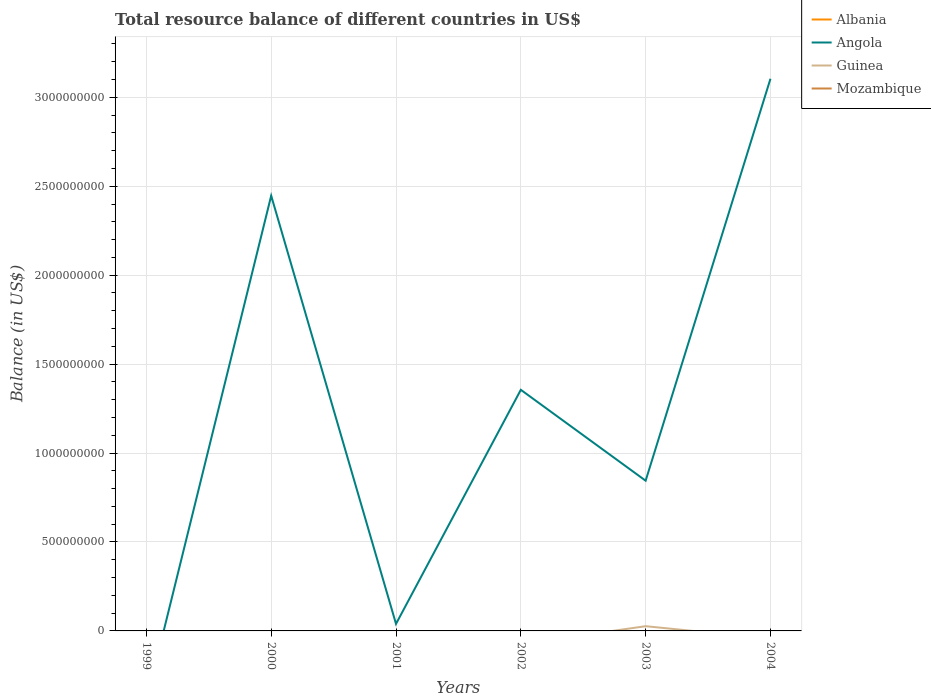How many different coloured lines are there?
Offer a very short reply. 2. Does the line corresponding to Angola intersect with the line corresponding to Mozambique?
Your answer should be very brief. No. Is the number of lines equal to the number of legend labels?
Offer a very short reply. No. What is the total total resource balance in Angola in the graph?
Your answer should be compact. -3.06e+09. What is the difference between the highest and the second highest total resource balance in Angola?
Give a very brief answer. 3.10e+09. How many lines are there?
Make the answer very short. 2. How many years are there in the graph?
Keep it short and to the point. 6. Are the values on the major ticks of Y-axis written in scientific E-notation?
Provide a short and direct response. No. Does the graph contain grids?
Your answer should be very brief. Yes. How many legend labels are there?
Provide a short and direct response. 4. What is the title of the graph?
Provide a short and direct response. Total resource balance of different countries in US$. Does "Latin America(developing only)" appear as one of the legend labels in the graph?
Provide a succinct answer. No. What is the label or title of the Y-axis?
Offer a terse response. Balance (in US$). What is the Balance (in US$) in Guinea in 1999?
Keep it short and to the point. 0. What is the Balance (in US$) of Mozambique in 1999?
Ensure brevity in your answer.  0. What is the Balance (in US$) in Angola in 2000?
Provide a short and direct response. 2.45e+09. What is the Balance (in US$) of Angola in 2001?
Provide a succinct answer. 3.95e+07. What is the Balance (in US$) of Guinea in 2001?
Your answer should be compact. 0. What is the Balance (in US$) in Albania in 2002?
Provide a short and direct response. 0. What is the Balance (in US$) in Angola in 2002?
Offer a terse response. 1.36e+09. What is the Balance (in US$) in Mozambique in 2002?
Provide a short and direct response. 0. What is the Balance (in US$) of Angola in 2003?
Provide a short and direct response. 8.45e+08. What is the Balance (in US$) of Guinea in 2003?
Your response must be concise. 2.66e+07. What is the Balance (in US$) of Albania in 2004?
Your response must be concise. 0. What is the Balance (in US$) of Angola in 2004?
Your answer should be very brief. 3.10e+09. What is the Balance (in US$) of Mozambique in 2004?
Ensure brevity in your answer.  0. Across all years, what is the maximum Balance (in US$) in Angola?
Provide a short and direct response. 3.10e+09. Across all years, what is the maximum Balance (in US$) in Guinea?
Offer a very short reply. 2.66e+07. Across all years, what is the minimum Balance (in US$) in Angola?
Keep it short and to the point. 0. What is the total Balance (in US$) in Albania in the graph?
Your response must be concise. 0. What is the total Balance (in US$) in Angola in the graph?
Provide a short and direct response. 7.79e+09. What is the total Balance (in US$) in Guinea in the graph?
Offer a terse response. 2.66e+07. What is the difference between the Balance (in US$) in Angola in 2000 and that in 2001?
Offer a terse response. 2.41e+09. What is the difference between the Balance (in US$) of Angola in 2000 and that in 2002?
Give a very brief answer. 1.09e+09. What is the difference between the Balance (in US$) in Angola in 2000 and that in 2003?
Your answer should be very brief. 1.60e+09. What is the difference between the Balance (in US$) in Angola in 2000 and that in 2004?
Keep it short and to the point. -6.58e+08. What is the difference between the Balance (in US$) in Angola in 2001 and that in 2002?
Provide a short and direct response. -1.32e+09. What is the difference between the Balance (in US$) in Angola in 2001 and that in 2003?
Provide a short and direct response. -8.05e+08. What is the difference between the Balance (in US$) in Angola in 2001 and that in 2004?
Provide a succinct answer. -3.06e+09. What is the difference between the Balance (in US$) in Angola in 2002 and that in 2003?
Your answer should be very brief. 5.11e+08. What is the difference between the Balance (in US$) in Angola in 2002 and that in 2004?
Keep it short and to the point. -1.75e+09. What is the difference between the Balance (in US$) of Angola in 2003 and that in 2004?
Give a very brief answer. -2.26e+09. What is the difference between the Balance (in US$) of Angola in 2000 and the Balance (in US$) of Guinea in 2003?
Keep it short and to the point. 2.42e+09. What is the difference between the Balance (in US$) of Angola in 2001 and the Balance (in US$) of Guinea in 2003?
Your answer should be compact. 1.30e+07. What is the difference between the Balance (in US$) in Angola in 2002 and the Balance (in US$) in Guinea in 2003?
Ensure brevity in your answer.  1.33e+09. What is the average Balance (in US$) in Angola per year?
Offer a terse response. 1.30e+09. What is the average Balance (in US$) in Guinea per year?
Make the answer very short. 4.43e+06. In the year 2003, what is the difference between the Balance (in US$) of Angola and Balance (in US$) of Guinea?
Provide a succinct answer. 8.18e+08. What is the ratio of the Balance (in US$) of Angola in 2000 to that in 2001?
Offer a very short reply. 61.88. What is the ratio of the Balance (in US$) in Angola in 2000 to that in 2002?
Offer a terse response. 1.8. What is the ratio of the Balance (in US$) of Angola in 2000 to that in 2003?
Offer a very short reply. 2.9. What is the ratio of the Balance (in US$) of Angola in 2000 to that in 2004?
Keep it short and to the point. 0.79. What is the ratio of the Balance (in US$) in Angola in 2001 to that in 2002?
Make the answer very short. 0.03. What is the ratio of the Balance (in US$) of Angola in 2001 to that in 2003?
Keep it short and to the point. 0.05. What is the ratio of the Balance (in US$) in Angola in 2001 to that in 2004?
Your answer should be very brief. 0.01. What is the ratio of the Balance (in US$) of Angola in 2002 to that in 2003?
Give a very brief answer. 1.6. What is the ratio of the Balance (in US$) in Angola in 2002 to that in 2004?
Offer a very short reply. 0.44. What is the ratio of the Balance (in US$) of Angola in 2003 to that in 2004?
Keep it short and to the point. 0.27. What is the difference between the highest and the second highest Balance (in US$) in Angola?
Keep it short and to the point. 6.58e+08. What is the difference between the highest and the lowest Balance (in US$) of Angola?
Offer a very short reply. 3.10e+09. What is the difference between the highest and the lowest Balance (in US$) in Guinea?
Your answer should be very brief. 2.66e+07. 